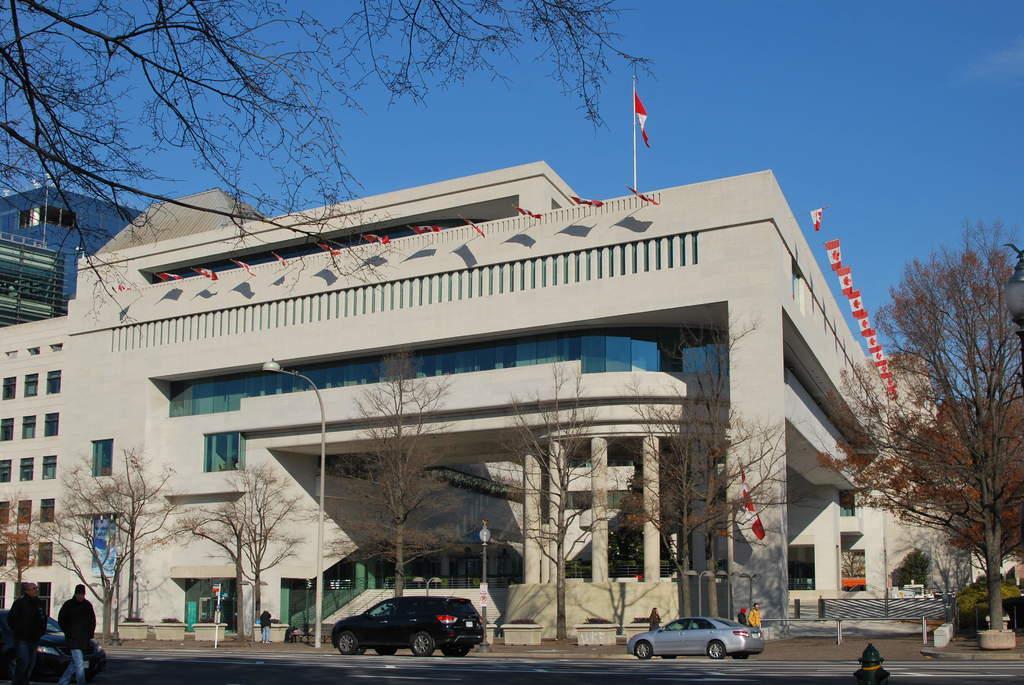Describe this image in one or two sentences. In this image in the center there are some buildings, trees, vehicles on the road. And also i can see some poles, lights, flags, railing and some persons are walking. And at the top of the image there is sky. 